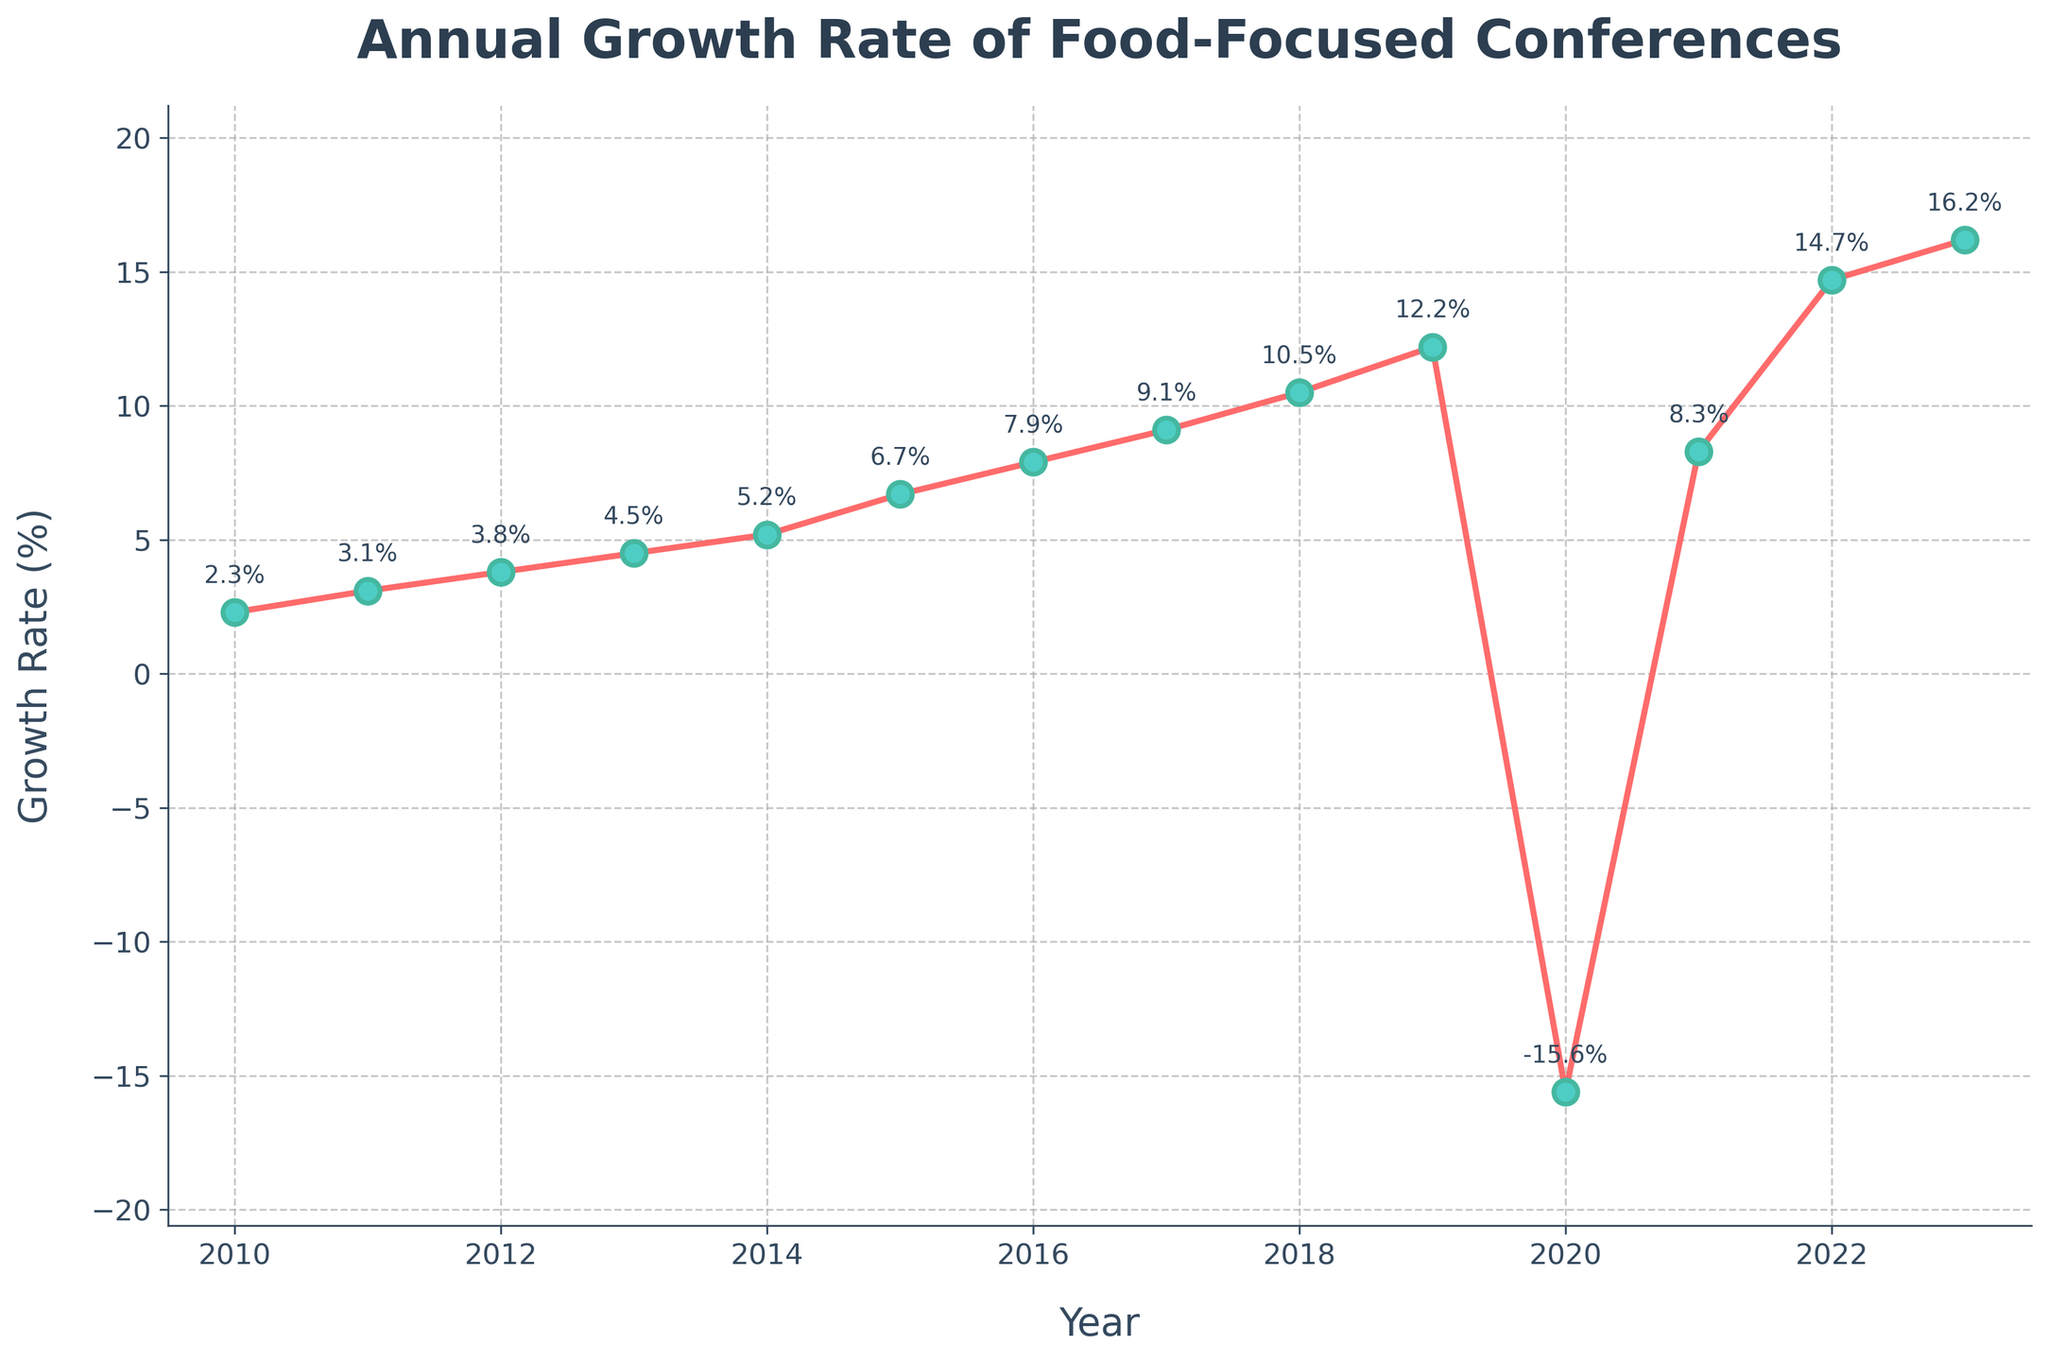What was the growth rate in 2020? Locate the data point corresponding to the year 2020 on the x-axis and read the value on the y-axis. The growth rate in 2020 is marked at -15.6%.
Answer: -15.6% Which year had the highest growth rate? Find the year with the highest value on the y-axis. The peak growth rate is 16.2%, which is marked in 2023.
Answer: 2023 What is the average growth rate for the years 2011 to 2015? Extract the values between 2011 and 2015: 3.1%, 3.8%, 4.5%, 5.2%, and 6.7%. Calculate the average: (3.1 + 3.8 + 4.5 + 5.2 + 6.7) / 5 = 23.3 / 5. The average is 4.66%.
Answer: 4.66% How does the growth rate in 2018 compare to that in 2021? Note the growth rate in 2018 (10.5%) and in 2021 (8.3%). Compare the two values. 10.5% is greater than 8.3%.
Answer: 2018 > 2021 What was the decrease in growth rate from 2019 to 2020? Find the growth rates for 2019 and 2020: 12.2% and -15.6%. Calculate the difference: 12.2 - (-15.6) = 12.2 + 15.6 = 27.8%.
Answer: 27.8% Which years had a growth rate greater than 10%? Identify the years where the y-axis value exceeds 10%. These years are 2018, 2019, 2022, and 2023.
Answer: 2018, 2019, 2022, 2023 What is the difference in growth rate between the year with the highest growth and the year with the lowest growth? The highest growth rate is 16.2% in 2023, and the lowest is -15.6% in 2020. Calculate the difference: 16.2 - (-15.6) = 16.2 + 15.6 = 31.8%.
Answer: 31.8% How does the growth trend from 2010 to 2019 differ from 2020 to 2023? Compare the slope between the two periods. From 2010 to 2019, the growth rate consistently increased from 2.3% to 12.2%, showing a positive trend. Between 2020 and 2023, there was a sharp drop to -15.6%, followed by a rapid recovery to 16.2%.
Answer: Positive trend (2010-2019), Sharp drop and recovery (2020-2023) What was the pattern of growth rate changes between 2012 and 2016? Between 2012 (3.8%) and 2016 (7.9%), the growth rate shows a consistent increasing trend over the years: 3.8%, 4.5%, 5.2%, 6.7%, 7.9%.
Answer: Consistent increase What is the visual characteristic of the growth rate marker in the plot? Describe the appearance of the markers: They are circular, marked with a color fill, and outlined with a different color edge to enhance visibility.
Answer: Circular markers with color fill and edge outlines 